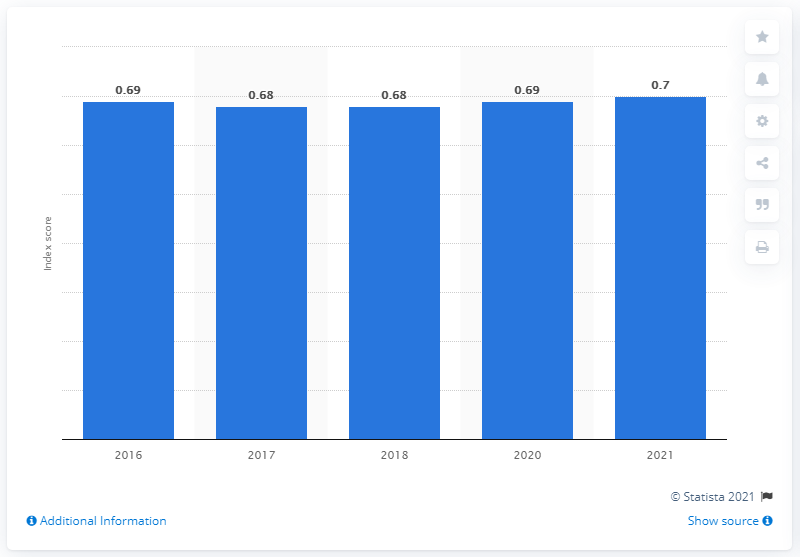Outline some significant characteristics in this image. In the year 2021, the gender gap index score in Brazil reached 0.695. 